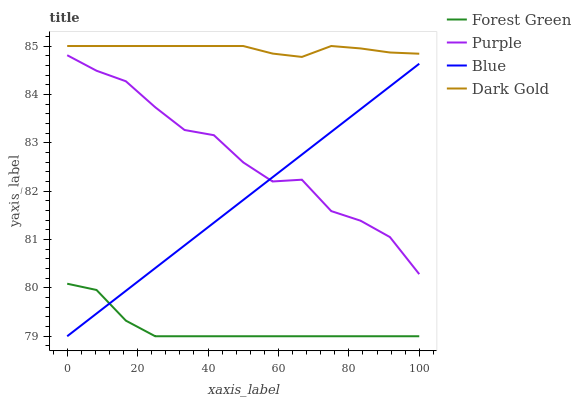Does Forest Green have the minimum area under the curve?
Answer yes or no. Yes. Does Dark Gold have the maximum area under the curve?
Answer yes or no. Yes. Does Blue have the minimum area under the curve?
Answer yes or no. No. Does Blue have the maximum area under the curve?
Answer yes or no. No. Is Blue the smoothest?
Answer yes or no. Yes. Is Purple the roughest?
Answer yes or no. Yes. Is Forest Green the smoothest?
Answer yes or no. No. Is Forest Green the roughest?
Answer yes or no. No. Does Blue have the lowest value?
Answer yes or no. Yes. Does Dark Gold have the lowest value?
Answer yes or no. No. Does Dark Gold have the highest value?
Answer yes or no. Yes. Does Blue have the highest value?
Answer yes or no. No. Is Forest Green less than Purple?
Answer yes or no. Yes. Is Dark Gold greater than Forest Green?
Answer yes or no. Yes. Does Forest Green intersect Blue?
Answer yes or no. Yes. Is Forest Green less than Blue?
Answer yes or no. No. Is Forest Green greater than Blue?
Answer yes or no. No. Does Forest Green intersect Purple?
Answer yes or no. No. 